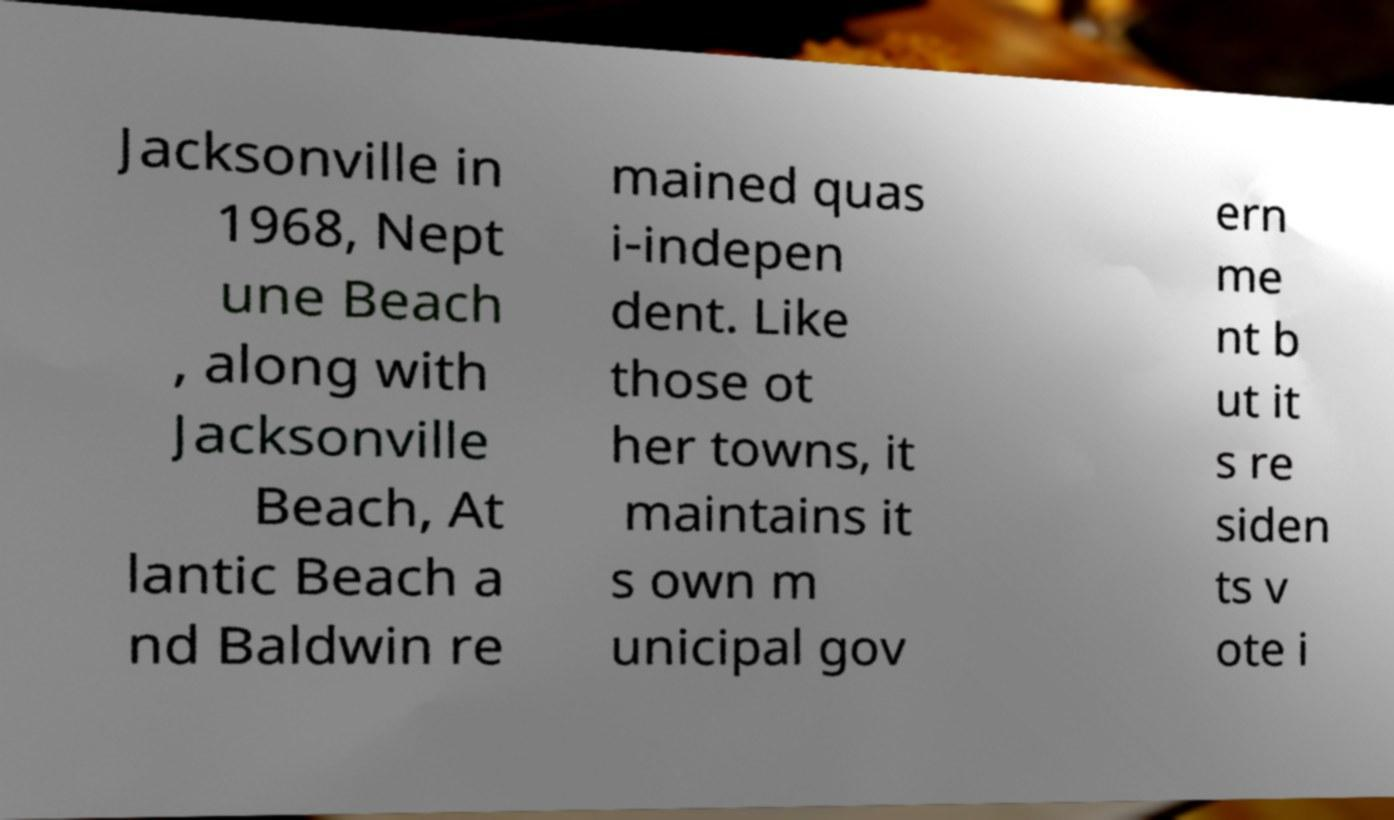Could you extract and type out the text from this image? Jacksonville in 1968, Nept une Beach , along with Jacksonville Beach, At lantic Beach a nd Baldwin re mained quas i-indepen dent. Like those ot her towns, it maintains it s own m unicipal gov ern me nt b ut it s re siden ts v ote i 